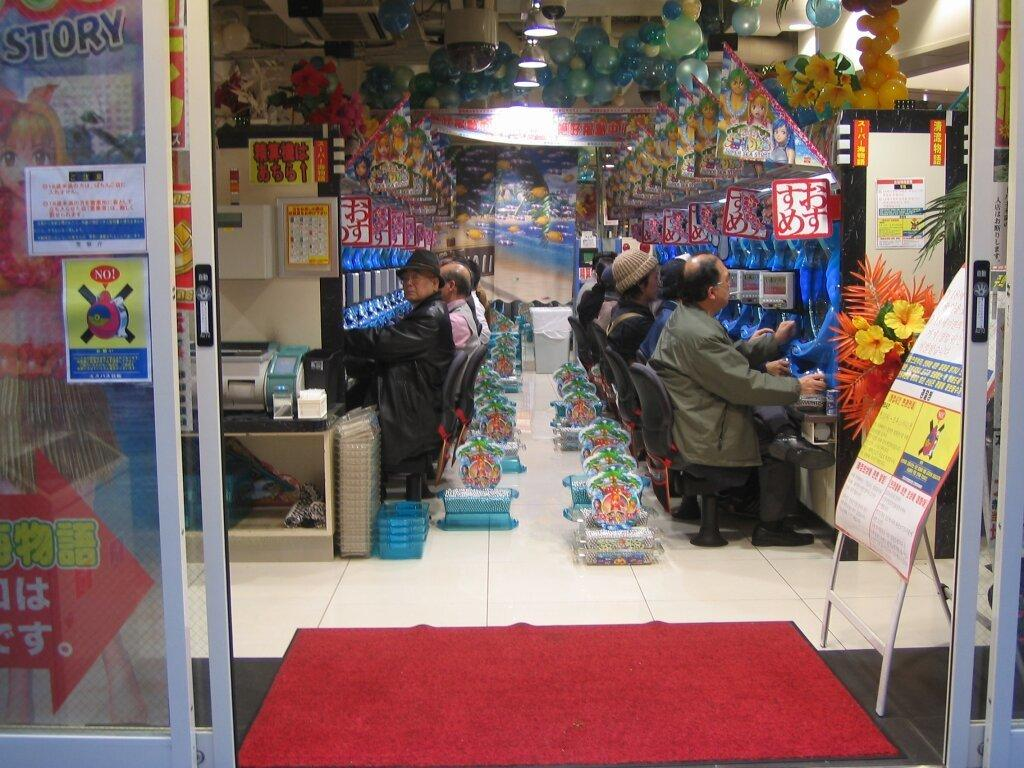<image>
Give a short and clear explanation of the subsequent image. Group of senior citizens playing arcade with a sticker that says Story outside. 